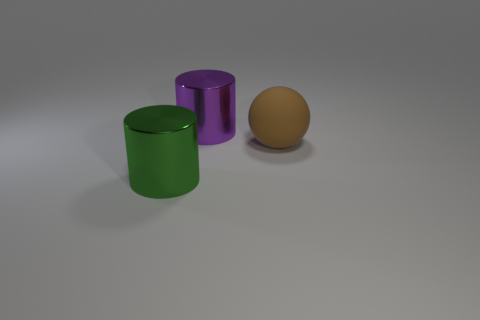Add 1 blue metallic things. How many objects exist? 4 Subtract all balls. How many objects are left? 2 Subtract 0 green balls. How many objects are left? 3 Subtract all small yellow rubber objects. Subtract all big green cylinders. How many objects are left? 2 Add 1 big brown things. How many big brown things are left? 2 Add 3 small cyan cylinders. How many small cyan cylinders exist? 3 